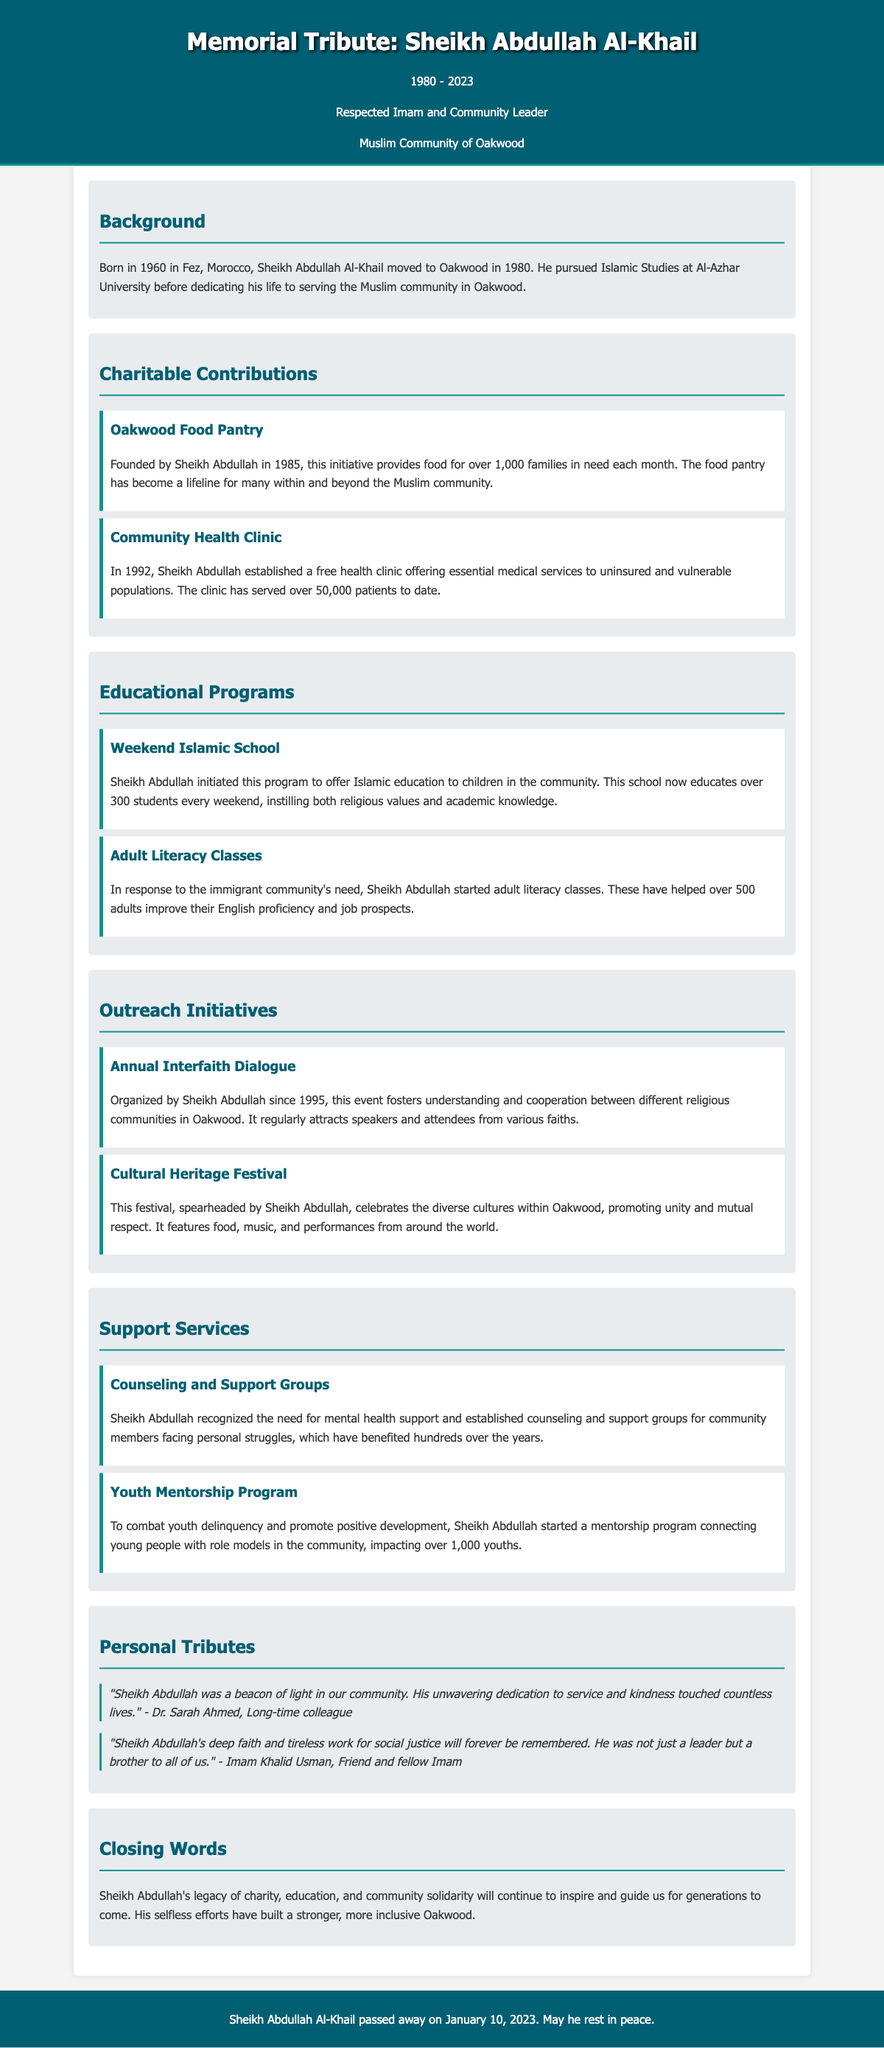What is the full name of the community leader? The document provides the full name of the community leader as Sheikh Abdullah Al-Khail.
Answer: Sheikh Abdullah Al-Khail In which year did Sheikh Abdullah Al-Khail establish the Oakwood Food Pantry? The document states that the Oakwood Food Pantry was founded by Sheikh Abdullah in 1985.
Answer: 1985 How many families does the Oakwood Food Pantry serve each month? According to the document, the food pantry provides food for over 1,000 families in need each month.
Answer: over 1,000 families What is the name of the free health clinic established by Sheikh Abdullah? The document refers to the free health clinic established by Sheikh Abdullah as the Community Health Clinic.
Answer: Community Health Clinic How many students does the Weekend Islamic School educate each weekend? The document mentions that the Weekend Islamic School educates over 300 students every weekend.
Answer: over 300 students What initiative was launched to promote understanding between different religious communities? The document indicates that the initiative organized by Sheikh Abdullah to promote understanding is the Annual Interfaith Dialogue.
Answer: Annual Interfaith Dialogue What year did Sheikh Abdullah initiate the Annual Interfaith Dialogue? The document states that Sheikh Abdullah has organized the Annual Interfaith Dialogue since 1995.
Answer: 1995 Which program was started to help adults improve their English proficiency? The document states that Sheikh Abdullah started the Adult Literacy Classes to help adults improve their English proficiency.
Answer: Adult Literacy Classes Who said, "Sheikh Abdullah was a beacon of light in our community"? The document quotes Dr. Sarah Ahmed as saying this about Sheikh Abdullah.
Answer: Dr. Sarah Ahmed 